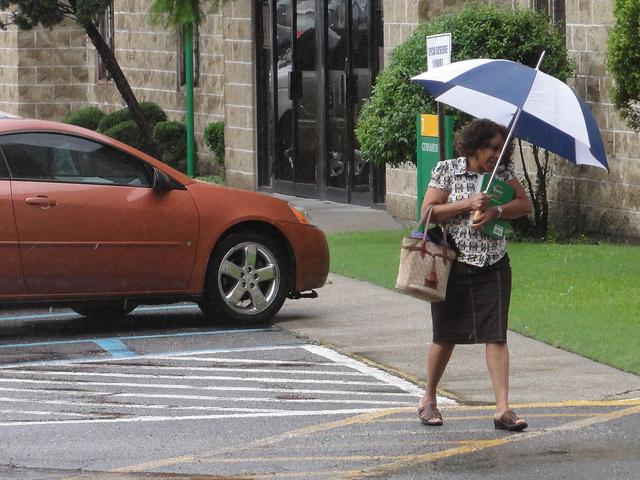What two primary colors have to be combined to get the color of the car? Please explain your reasoning. redyellow. It is orange 